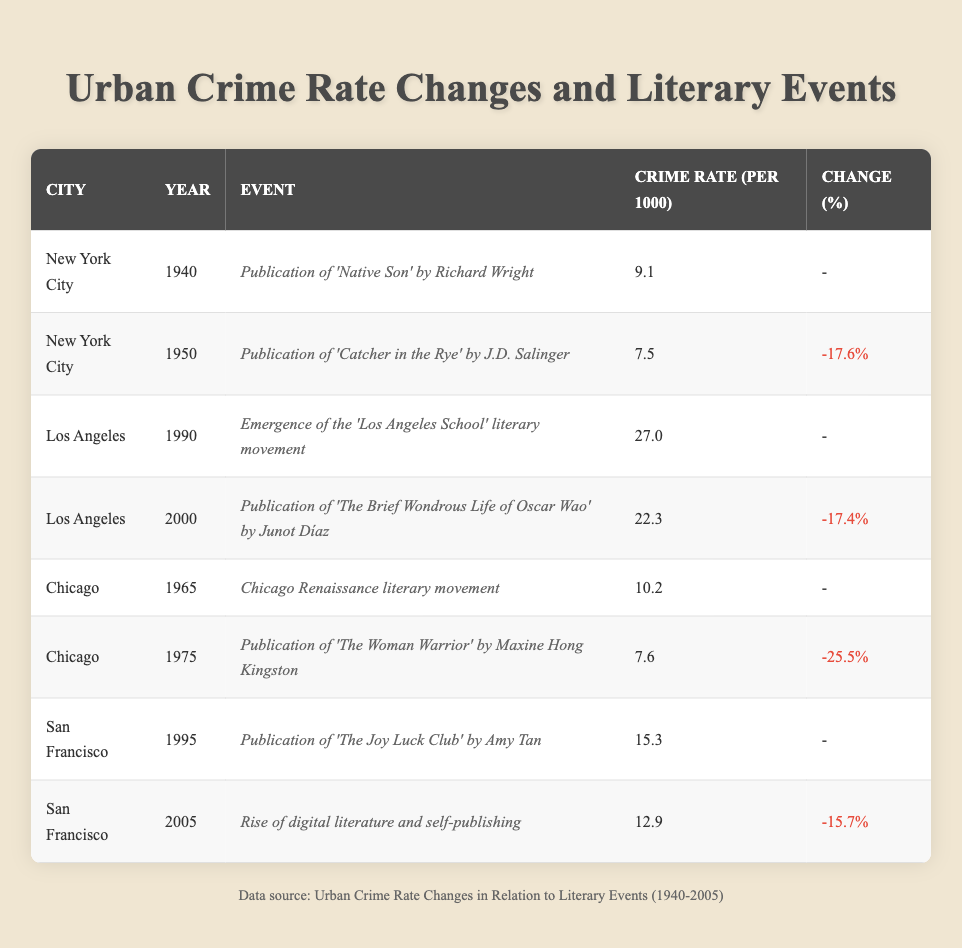What was the crime rate per 1000 in New York City in 1950? The table shows that in New York City in 1950, the crime rate was recorded at 7.5 per 1000.
Answer: 7.5 What was the percentage change in crime rate for Los Angeles from 1990 to 2000? In 1990, the crime rate was 27.0, and in 2000, it was 22.3. To find the percentage change, we first calculate the difference: 27.0 - 22.3 = 4.7. Then, we calculate the percentage change using the formula (change/original) * 100, which is (4.7/27.0) * 100 ≈ 17.4%. Thus, the change is -17.4%.
Answer: -17.4% Was there a documented crime rate change following the Chicago Renaissance literary movement in 1965? The table indicates that no change percentage is recorded for the Chicago Renaissance movement in 1965. Therefore, it cannot be determined from the data.
Answer: No What is the average crime rate per 1000 for San Francisco during the years surveyed? In the table, San Francisco's crime rates are 15.3 (1995) and 12.9 (2005). To find the average, we sum these values: 15.3 + 12.9 = 28.2. Then, divide by the number of data points, which is 2: 28.2 / 2 = 14.1.
Answer: 14.1 Which literary event correlated with the largest crime rate decrease in Chicago? The table shows two entries for Chicago: one in 1965 with no change percentage and another in 1975 for "The Woman Warrior" by Maxine Hong Kingston, which had a -25.5% change. Therefore, the 1975 event corresponds to the largest crime rate decrease for Chicago.
Answer: The Woman Warrior What is the total number of recorded literary events that correspond with crime rate data from the provided table? By counting each unique event in the table, we find there are 8 events recorded that correspond with crime rate data.
Answer: 8 Was there an increase in crime rate in New York City after the publication of "Catcher in the Rye" in 1950? The crime rate in New York City decreased from 9.1 in 1940 to 7.5 in 1950 following the publication of "Catcher in the Rye." Therefore, there was a decrease, not an increase.
Answer: No Which city had the highest crime rate per 1000 recorded, and what was it? The table provides that Los Angeles had the highest crime rate recorded at 27.0 per 1000 in 1990.
Answer: Los Angeles, 27.0 